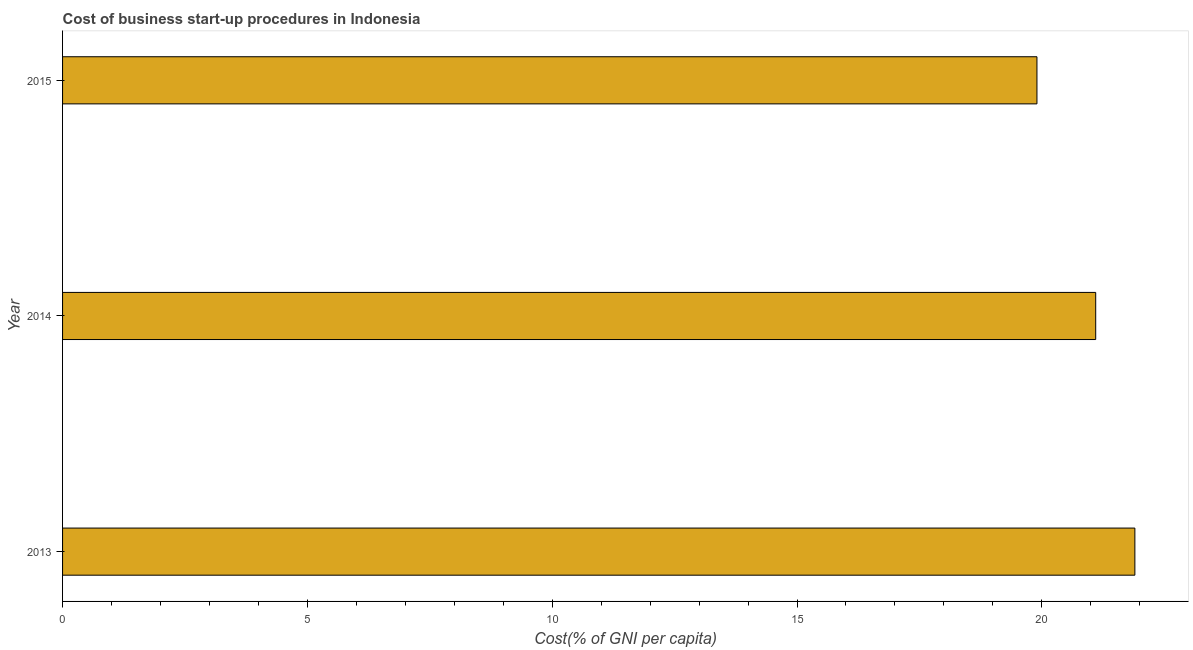Does the graph contain any zero values?
Offer a terse response. No. What is the title of the graph?
Your answer should be compact. Cost of business start-up procedures in Indonesia. What is the label or title of the X-axis?
Make the answer very short. Cost(% of GNI per capita). What is the label or title of the Y-axis?
Your response must be concise. Year. What is the cost of business startup procedures in 2013?
Give a very brief answer. 21.9. Across all years, what is the maximum cost of business startup procedures?
Keep it short and to the point. 21.9. In which year was the cost of business startup procedures minimum?
Make the answer very short. 2015. What is the sum of the cost of business startup procedures?
Your answer should be compact. 62.9. What is the difference between the cost of business startup procedures in 2014 and 2015?
Your answer should be compact. 1.2. What is the average cost of business startup procedures per year?
Ensure brevity in your answer.  20.97. What is the median cost of business startup procedures?
Give a very brief answer. 21.1. In how many years, is the cost of business startup procedures greater than 19 %?
Your answer should be compact. 3. Do a majority of the years between 2014 and 2013 (inclusive) have cost of business startup procedures greater than 12 %?
Make the answer very short. No. What is the ratio of the cost of business startup procedures in 2013 to that in 2014?
Keep it short and to the point. 1.04. Is the cost of business startup procedures in 2013 less than that in 2014?
Give a very brief answer. No. Is the difference between the cost of business startup procedures in 2014 and 2015 greater than the difference between any two years?
Provide a short and direct response. No. Is the sum of the cost of business startup procedures in 2014 and 2015 greater than the maximum cost of business startup procedures across all years?
Ensure brevity in your answer.  Yes. What is the difference between the highest and the lowest cost of business startup procedures?
Give a very brief answer. 2. How many bars are there?
Offer a very short reply. 3. How many years are there in the graph?
Provide a short and direct response. 3. What is the Cost(% of GNI per capita) in 2013?
Give a very brief answer. 21.9. What is the Cost(% of GNI per capita) in 2014?
Your answer should be compact. 21.1. What is the ratio of the Cost(% of GNI per capita) in 2013 to that in 2014?
Your answer should be compact. 1.04. What is the ratio of the Cost(% of GNI per capita) in 2013 to that in 2015?
Offer a terse response. 1.1. What is the ratio of the Cost(% of GNI per capita) in 2014 to that in 2015?
Make the answer very short. 1.06. 